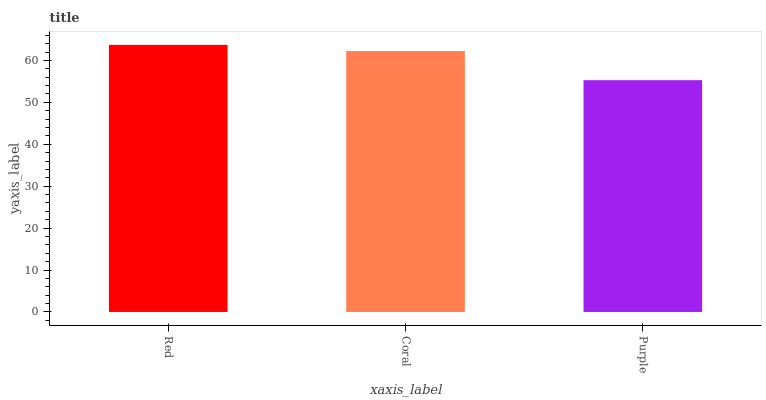Is Coral the minimum?
Answer yes or no. No. Is Coral the maximum?
Answer yes or no. No. Is Red greater than Coral?
Answer yes or no. Yes. Is Coral less than Red?
Answer yes or no. Yes. Is Coral greater than Red?
Answer yes or no. No. Is Red less than Coral?
Answer yes or no. No. Is Coral the high median?
Answer yes or no. Yes. Is Coral the low median?
Answer yes or no. Yes. Is Red the high median?
Answer yes or no. No. Is Purple the low median?
Answer yes or no. No. 